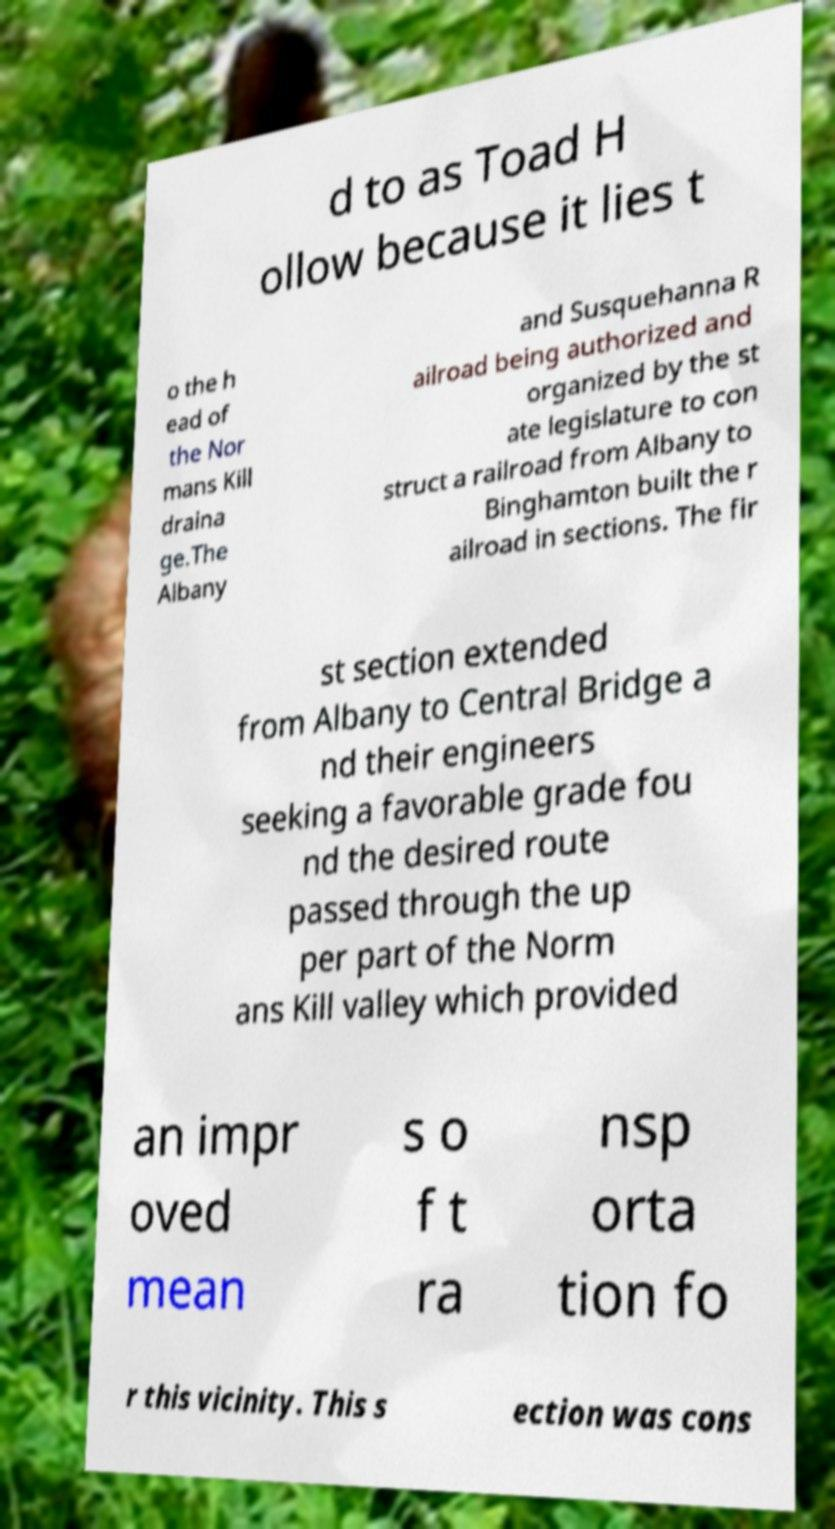Could you assist in decoding the text presented in this image and type it out clearly? d to as Toad H ollow because it lies t o the h ead of the Nor mans Kill draina ge.The Albany and Susquehanna R ailroad being authorized and organized by the st ate legislature to con struct a railroad from Albany to Binghamton built the r ailroad in sections. The fir st section extended from Albany to Central Bridge a nd their engineers seeking a favorable grade fou nd the desired route passed through the up per part of the Norm ans Kill valley which provided an impr oved mean s o f t ra nsp orta tion fo r this vicinity. This s ection was cons 